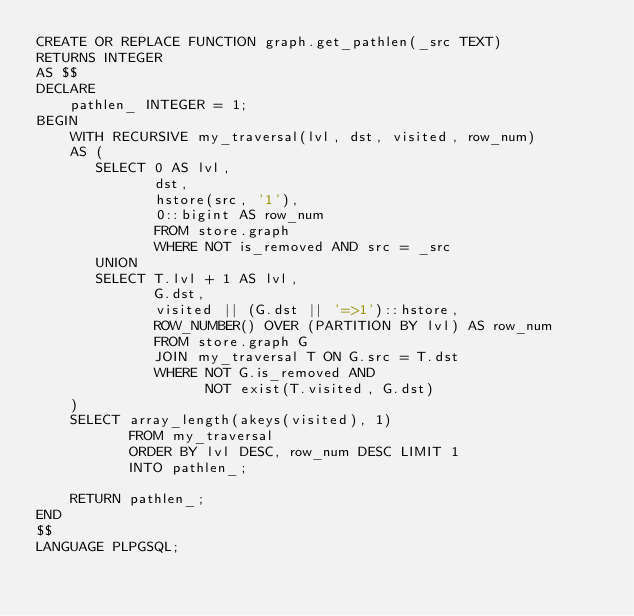Convert code to text. <code><loc_0><loc_0><loc_500><loc_500><_SQL_>CREATE OR REPLACE FUNCTION graph.get_pathlen(_src TEXT)
RETURNS INTEGER
AS $$
DECLARE
    pathlen_ INTEGER = 1;
BEGIN
    WITH RECURSIVE my_traversal(lvl, dst, visited, row_num)
    AS (
       SELECT 0 AS lvl,
              dst,
              hstore(src, '1'),
              0::bigint AS row_num
              FROM store.graph
              WHERE NOT is_removed AND src = _src
       UNION
       SELECT T.lvl + 1 AS lvl,
              G.dst,
              visited || (G.dst || '=>1')::hstore,
              ROW_NUMBER() OVER (PARTITION BY lvl) AS row_num
              FROM store.graph G
              JOIN my_traversal T ON G.src = T.dst
              WHERE NOT G.is_removed AND
                    NOT exist(T.visited, G.dst)
    )
    SELECT array_length(akeys(visited), 1)
           FROM my_traversal
           ORDER BY lvl DESC, row_num DESC LIMIT 1
           INTO pathlen_;

    RETURN pathlen_;
END
$$
LANGUAGE PLPGSQL;
</code> 